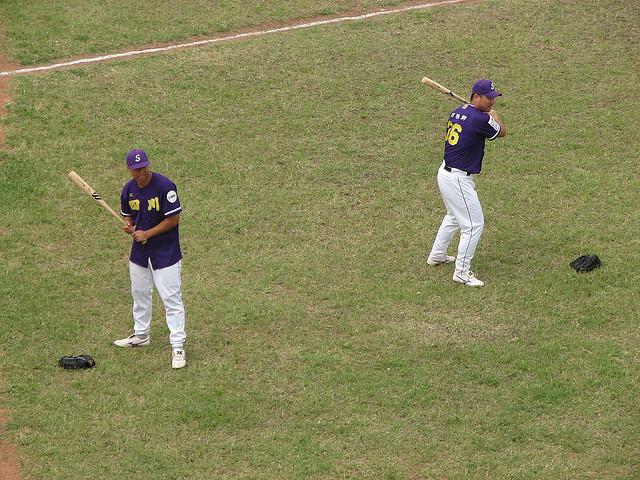What game is being played?
Quick response, please. Baseball. How many bats are there?
Give a very brief answer. 2. Are these players professional?
Give a very brief answer. Yes. What are the black objects near the two men?
Concise answer only. Gloves. What color is the bat?
Give a very brief answer. Brown. 